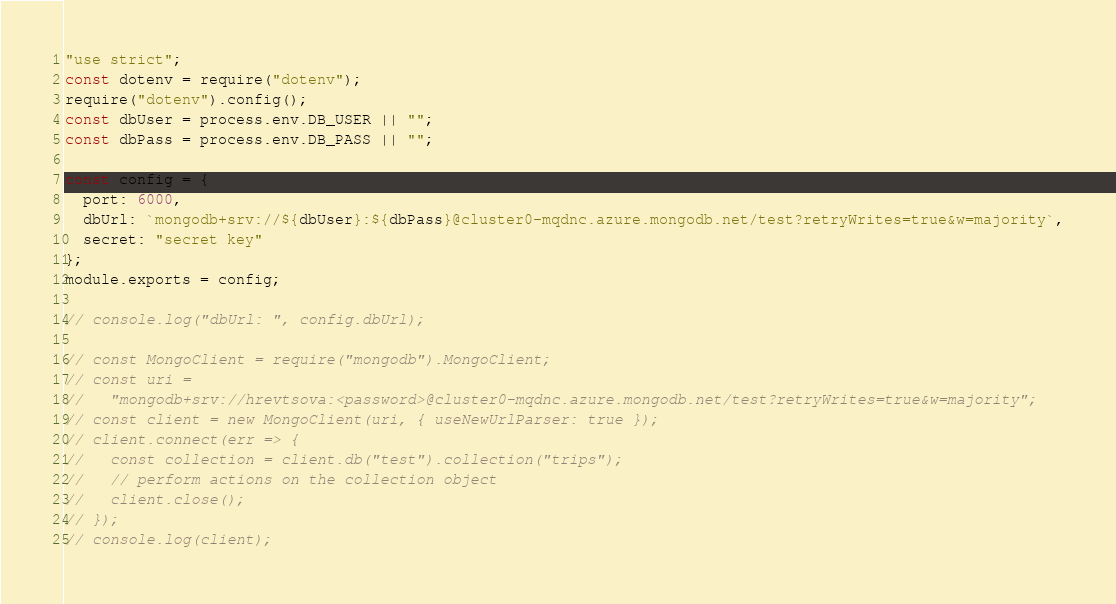Convert code to text. <code><loc_0><loc_0><loc_500><loc_500><_JavaScript_>"use strict";
const dotenv = require("dotenv");
require("dotenv").config();
const dbUser = process.env.DB_USER || "";
const dbPass = process.env.DB_PASS || "";

const config = {
  port: 6000,
  dbUrl: `mongodb+srv://${dbUser}:${dbPass}@cluster0-mqdnc.azure.mongodb.net/test?retryWrites=true&w=majority`,
  secret: "secret key"
};
module.exports = config;

// console.log("dbUrl: ", config.dbUrl);

// const MongoClient = require("mongodb").MongoClient;
// const uri =
//   "mongodb+srv://hrevtsova:<password>@cluster0-mqdnc.azure.mongodb.net/test?retryWrites=true&w=majority";
// const client = new MongoClient(uri, { useNewUrlParser: true });
// client.connect(err => {
//   const collection = client.db("test").collection("trips");
//   // perform actions on the collection object
//   client.close();
// });
// console.log(client);
</code> 